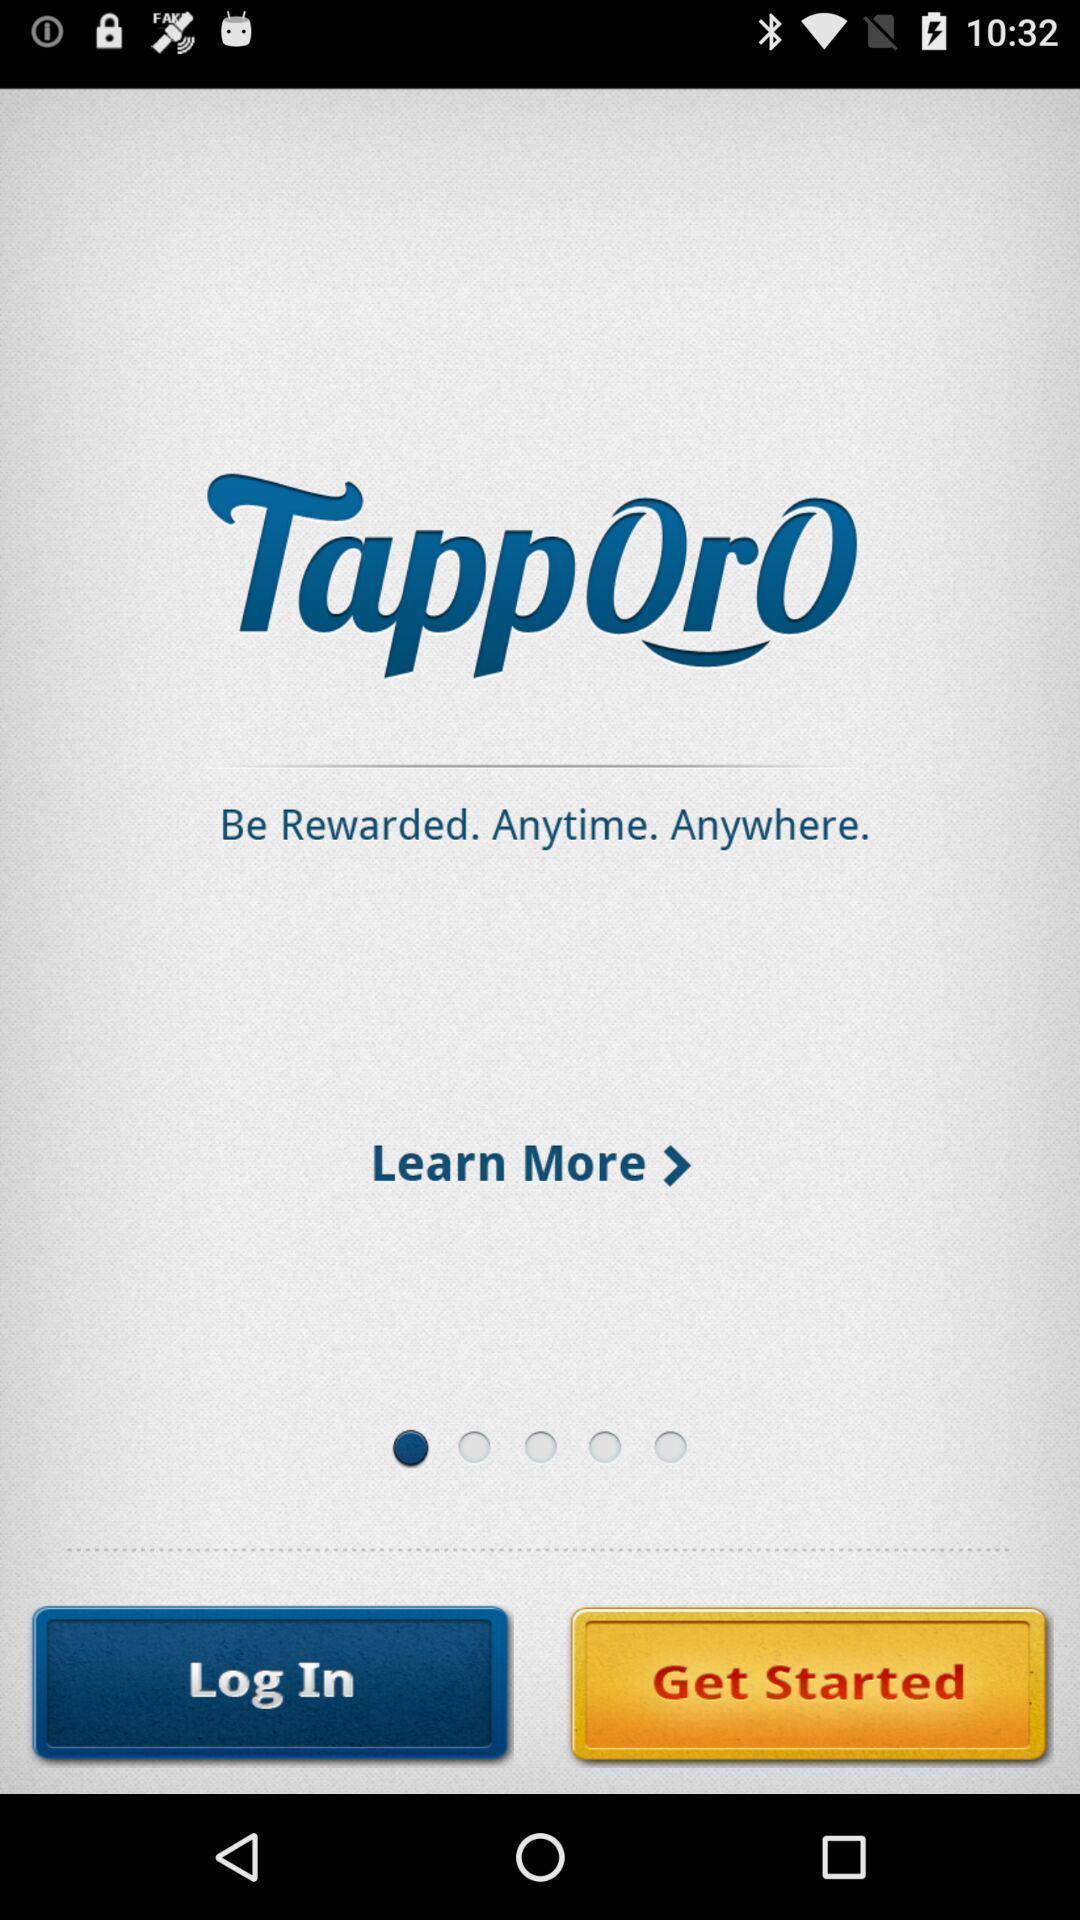Describe the visual elements of this screenshot. Welcome page. 